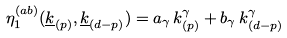Convert formula to latex. <formula><loc_0><loc_0><loc_500><loc_500>\eta ^ { ( a b ) } _ { 1 } ( \underline { k } _ { ( p ) } , \underline { k } _ { ( d - p ) } ) = a _ { \gamma } \, k _ { ( p ) } ^ { \gamma } + b _ { \gamma } \, k _ { ( d - p ) } ^ { \gamma }</formula> 